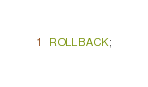<code> <loc_0><loc_0><loc_500><loc_500><_SQL_>ROLLBACK;
</code> 